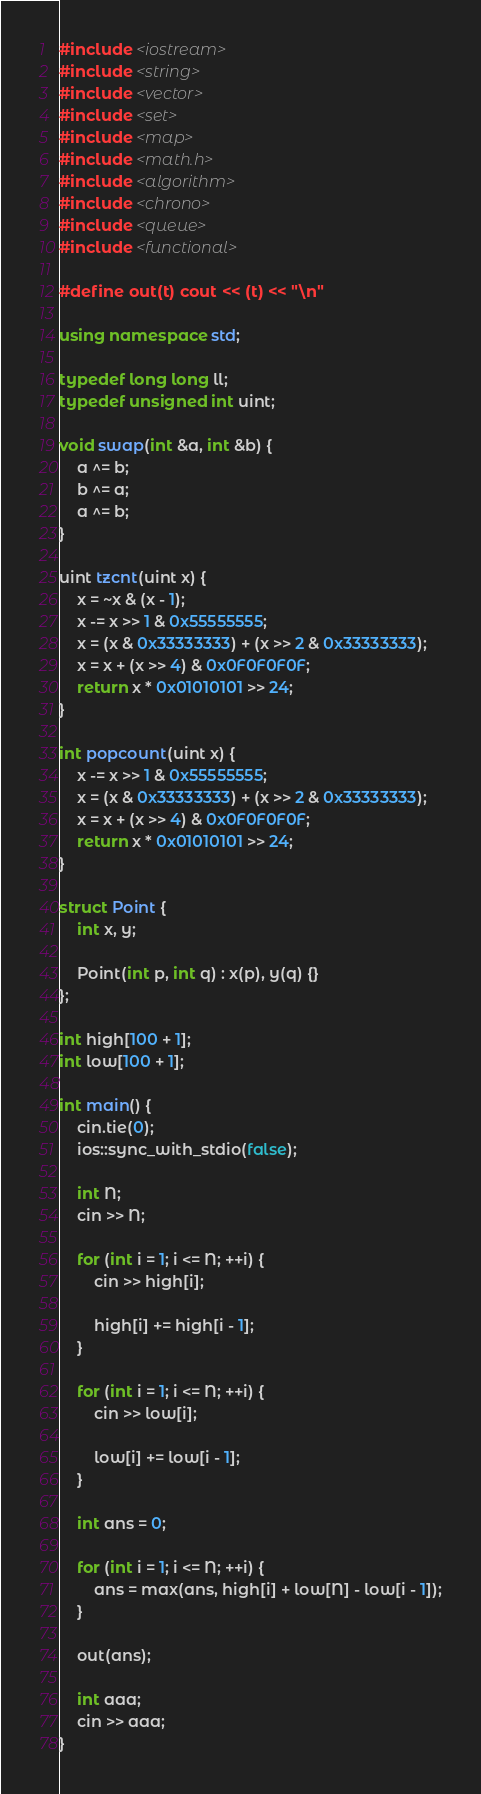<code> <loc_0><loc_0><loc_500><loc_500><_C++_>#include <iostream>
#include <string>
#include <vector>
#include <set>
#include <map>
#include <math.h>
#include <algorithm>
#include <chrono>
#include <queue>
#include <functional>

#define out(t) cout << (t) << "\n"

using namespace std;

typedef long long ll;
typedef unsigned int uint;

void swap(int &a, int &b) {
    a ^= b;
    b ^= a;
    a ^= b;
}

uint tzcnt(uint x) {
    x = ~x & (x - 1);
    x -= x >> 1 & 0x55555555;
    x = (x & 0x33333333) + (x >> 2 & 0x33333333);
    x = x + (x >> 4) & 0x0F0F0F0F;
    return x * 0x01010101 >> 24;
}

int popcount(uint x) {
    x -= x >> 1 & 0x55555555;
    x = (x & 0x33333333) + (x >> 2 & 0x33333333);
    x = x + (x >> 4) & 0x0F0F0F0F;
    return x * 0x01010101 >> 24;
}

struct Point {
    int x, y;

    Point(int p, int q) : x(p), y(q) {}
};

int high[100 + 1];
int low[100 + 1];

int main() {
    cin.tie(0);
    ios::sync_with_stdio(false);

    int N;
    cin >> N;

    for (int i = 1; i <= N; ++i) {
        cin >> high[i];

        high[i] += high[i - 1];
    }

    for (int i = 1; i <= N; ++i) {
        cin >> low[i];

        low[i] += low[i - 1];
    }

    int ans = 0;

    for (int i = 1; i <= N; ++i) {
        ans = max(ans, high[i] + low[N] - low[i - 1]);
    }

    out(ans);

    int aaa;
    cin >> aaa;
}</code> 